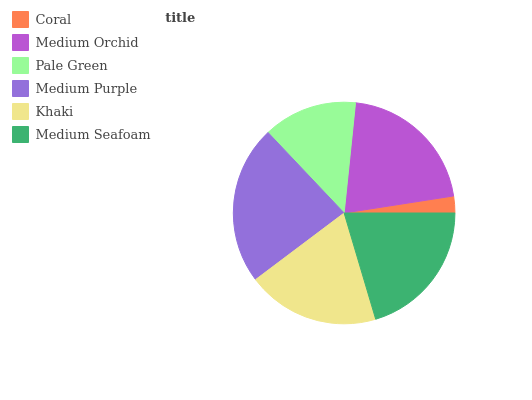Is Coral the minimum?
Answer yes or no. Yes. Is Medium Purple the maximum?
Answer yes or no. Yes. Is Medium Orchid the minimum?
Answer yes or no. No. Is Medium Orchid the maximum?
Answer yes or no. No. Is Medium Orchid greater than Coral?
Answer yes or no. Yes. Is Coral less than Medium Orchid?
Answer yes or no. Yes. Is Coral greater than Medium Orchid?
Answer yes or no. No. Is Medium Orchid less than Coral?
Answer yes or no. No. Is Medium Seafoam the high median?
Answer yes or no. Yes. Is Khaki the low median?
Answer yes or no. Yes. Is Medium Purple the high median?
Answer yes or no. No. Is Medium Purple the low median?
Answer yes or no. No. 